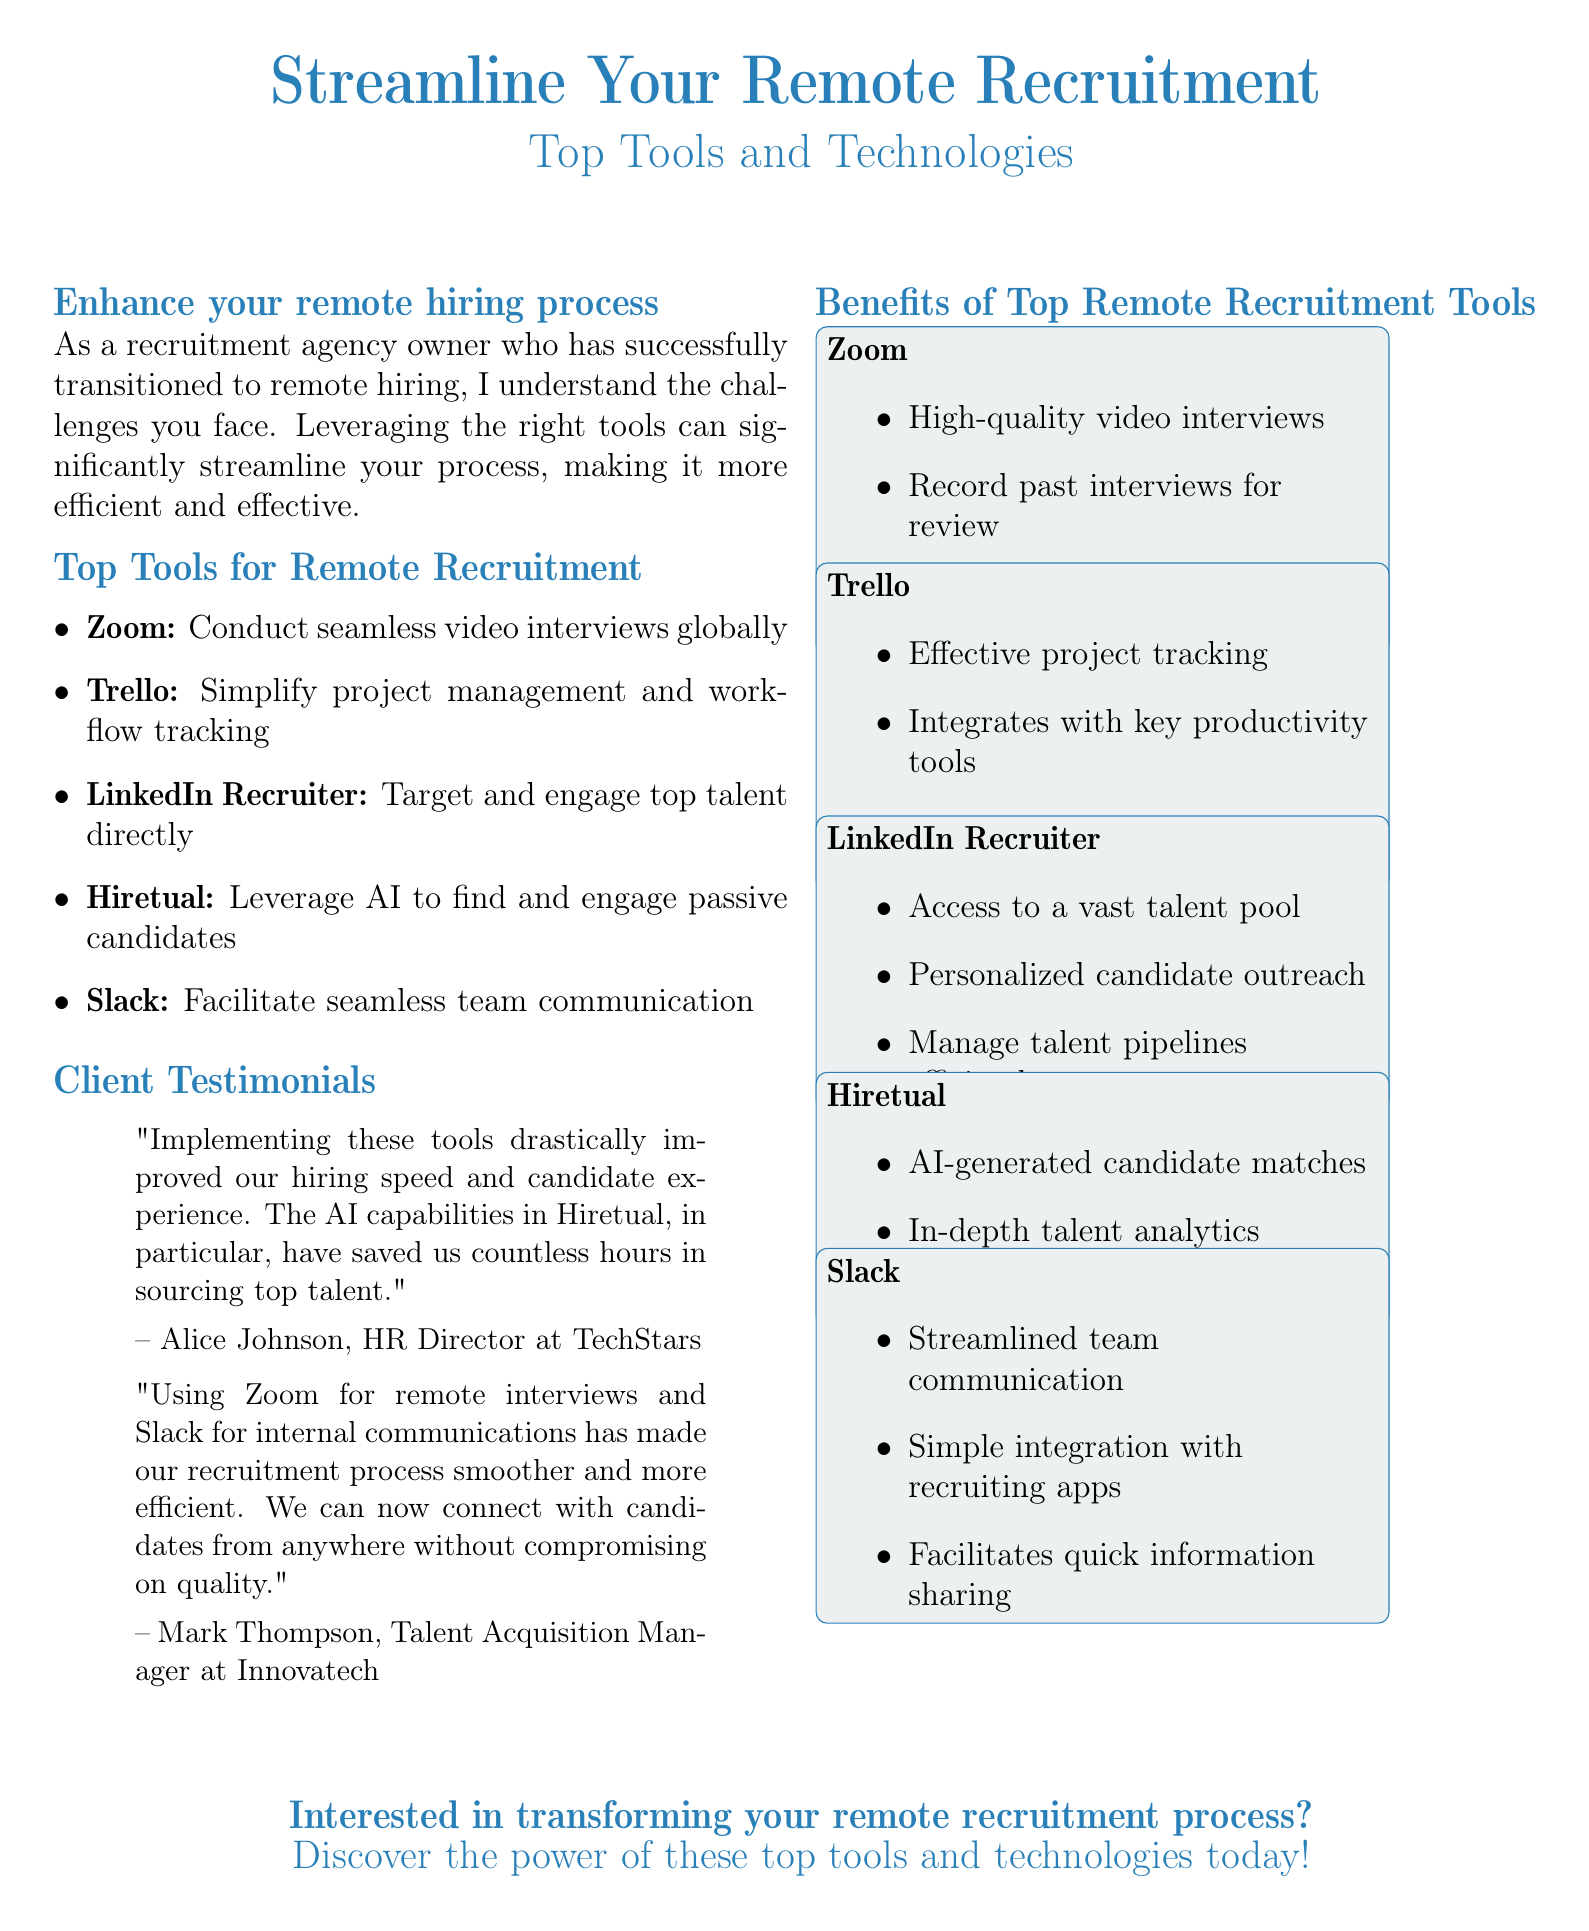What is the main topic of the advertisement? The main topic is centered around improving the recruitment process for remote hiring through specific tools and technologies.
Answer: Streamline Your Remote Recruitment How many tools are listed for remote recruitment? The document lists five tools that are recommended for enhancing remote recruitment processes.
Answer: Five Which video conferencing tool is mentioned? The advertisement references a popular platform used for video interviews in the recruitment process.
Answer: Zoom Who is the HR Director at TechStars? The document features a positive testimony from a client, revealing their name and position at a specific company.
Answer: Alice Johnson What feature does Hiretual provide to aid in recruitment? The document highlights a specific technology that utilizes artificial intelligence to assist recruiters in identifying candidates.
Answer: AI-generated candidate matches Which tool is recommended for project management? The advertisement mentions a tool designed to simplify project management and track workflow for recruiting teams.
Answer: Trello What type of interviews can be conducted using Zoom? The document specifies the type of interactions that users can perform with candidates through this platform.
Answer: Video interviews How does Slack facilitate recruitment? The advertisement identifies the primary function of this communication tool in the recruitment process.
Answer: Streamlined team communication 